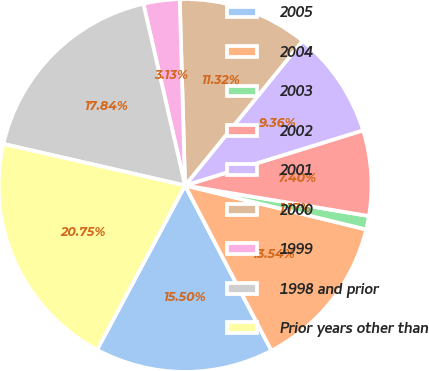Convert chart. <chart><loc_0><loc_0><loc_500><loc_500><pie_chart><fcel>2005<fcel>2004<fcel>2003<fcel>2002<fcel>2001<fcel>2000<fcel>1999<fcel>1998 and prior<fcel>Prior years other than<nl><fcel>15.5%<fcel>13.54%<fcel>1.17%<fcel>7.4%<fcel>9.36%<fcel>11.32%<fcel>3.13%<fcel>17.84%<fcel>20.75%<nl></chart> 